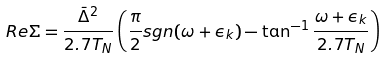<formula> <loc_0><loc_0><loc_500><loc_500>R e \Sigma = \frac { \bar { \Delta } ^ { 2 } } { 2 . 7 T _ { N } } \left ( \frac { \pi } { 2 } s g n ( \omega + \epsilon _ { k } ) - \tan ^ { - 1 } \frac { \omega + \epsilon _ { k } } { 2 . 7 T _ { N } } \right )</formula> 